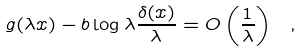<formula> <loc_0><loc_0><loc_500><loc_500>g ( \lambda x ) - b \log \lambda \frac { \delta ( x ) } { \lambda } = O \left ( \frac { 1 } { \lambda } \right ) \ ,</formula> 